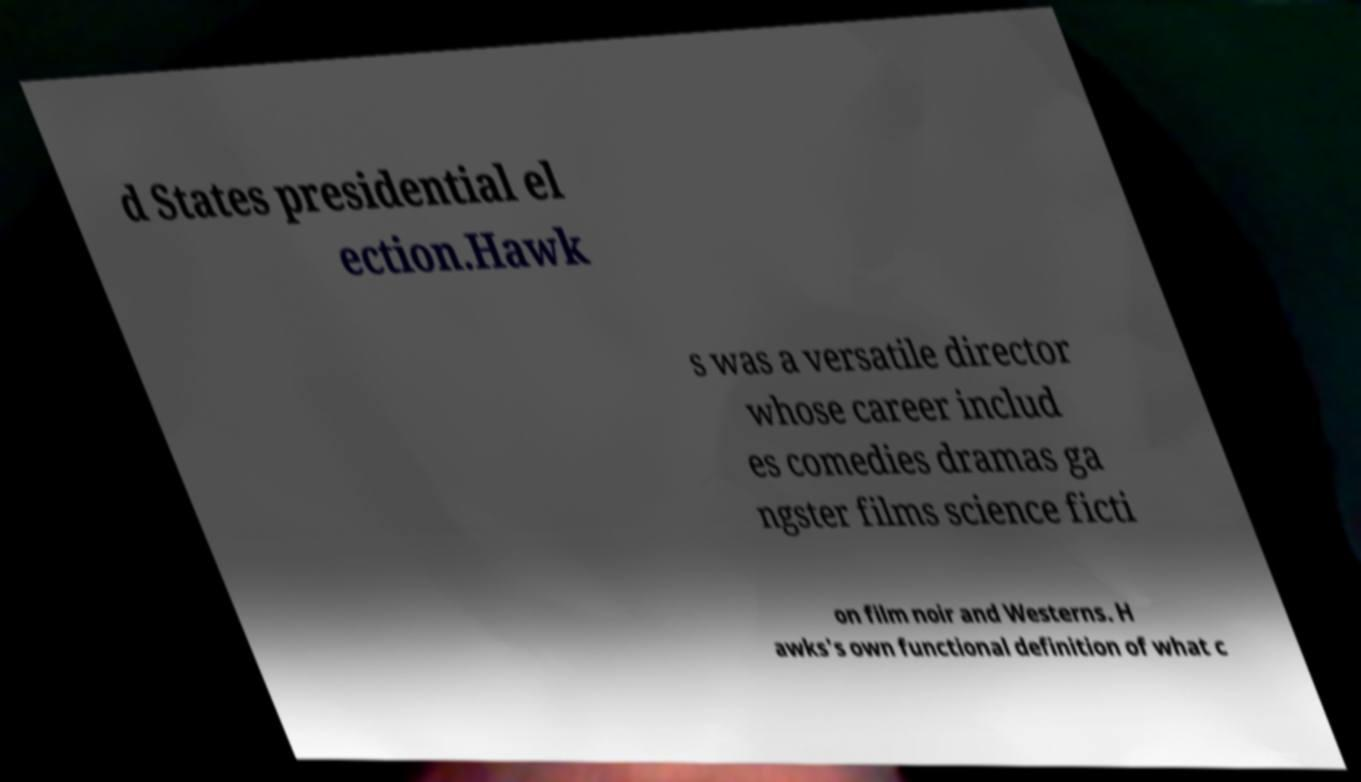For documentation purposes, I need the text within this image transcribed. Could you provide that? d States presidential el ection.Hawk s was a versatile director whose career includ es comedies dramas ga ngster films science ficti on film noir and Westerns. H awks's own functional definition of what c 